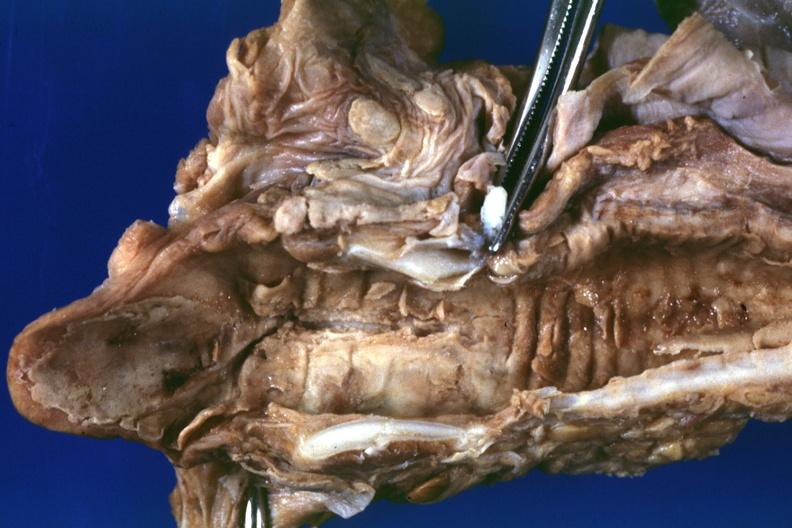where is this?
Answer the question using a single word or phrase. Oral 